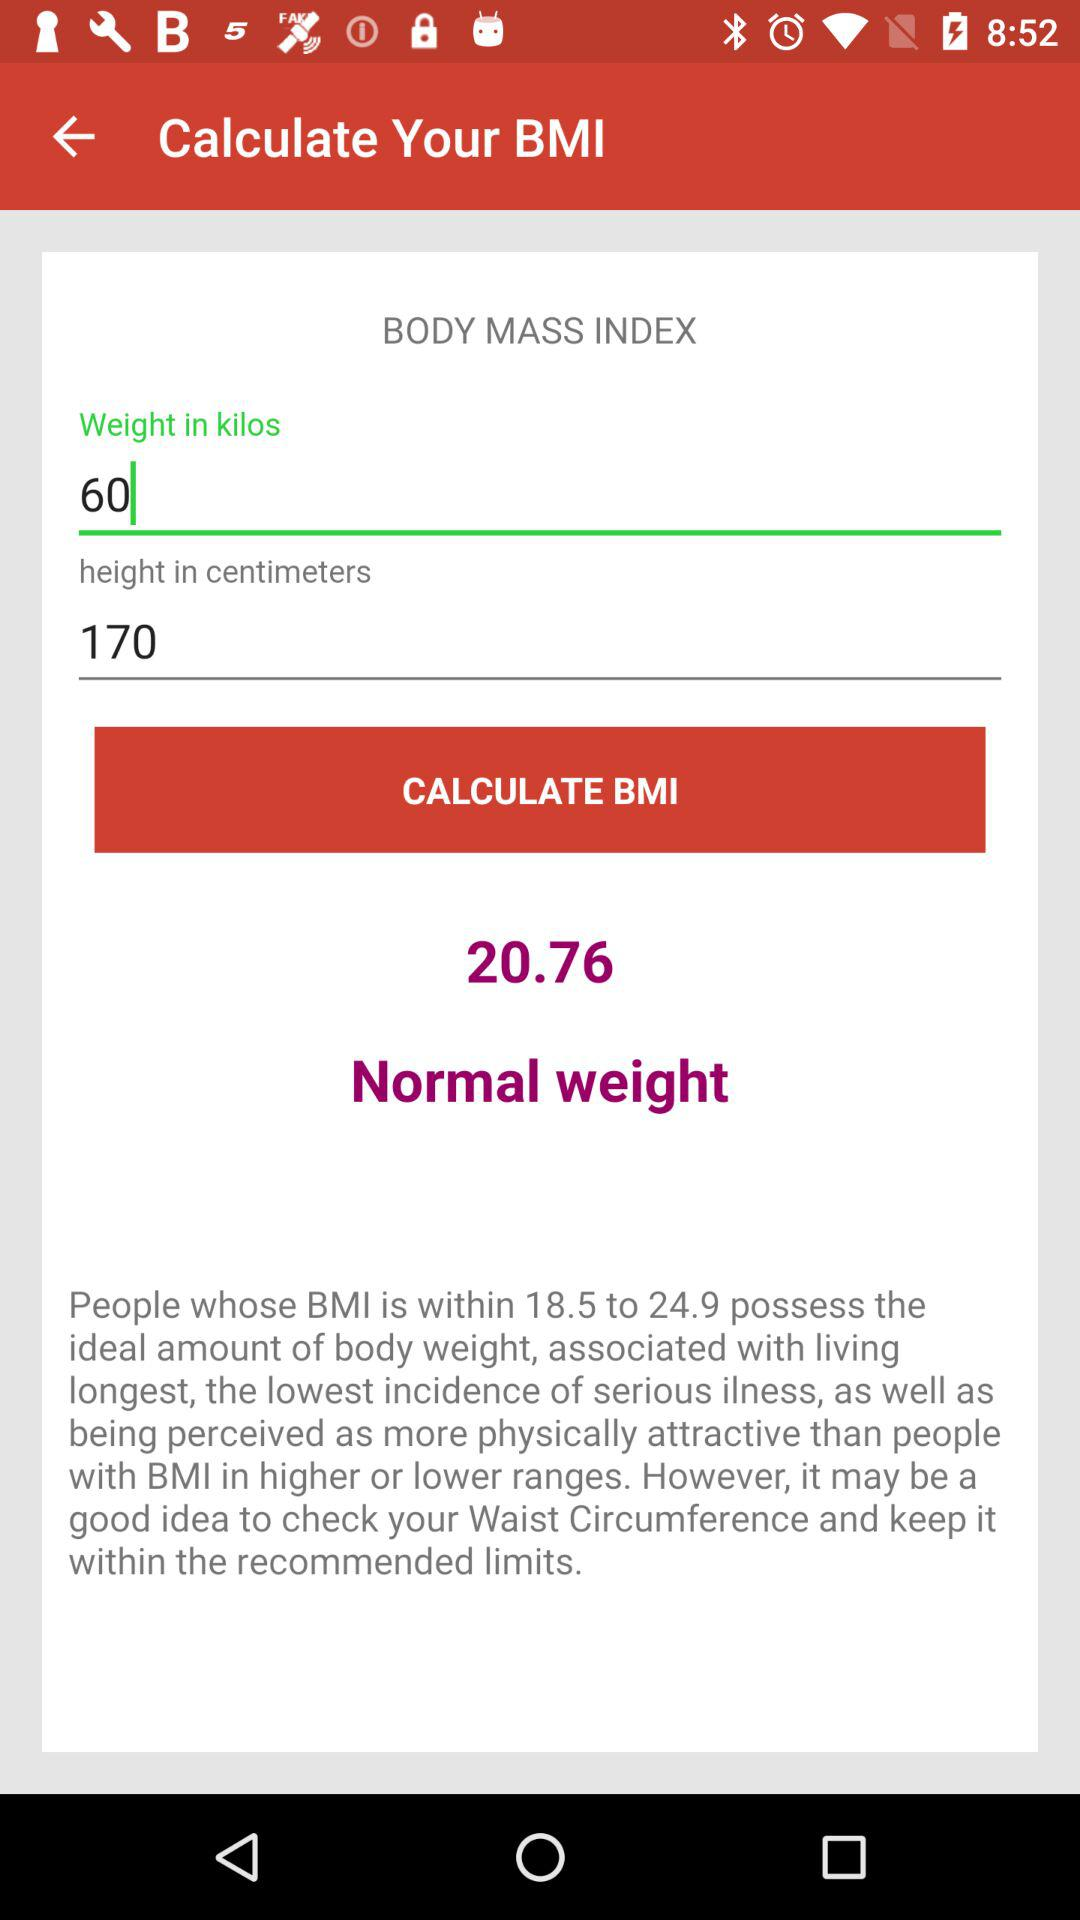What is the user's BMI?
Answer the question using a single word or phrase. 20.76 